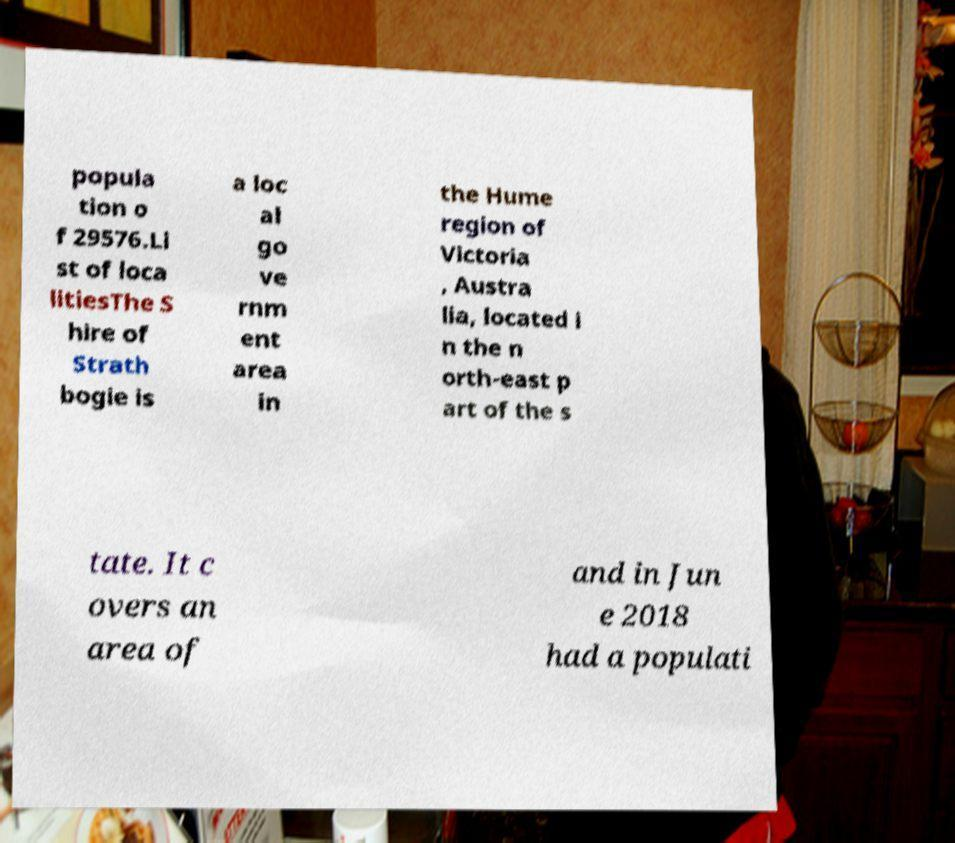For documentation purposes, I need the text within this image transcribed. Could you provide that? popula tion o f 29576.Li st of loca litiesThe S hire of Strath bogie is a loc al go ve rnm ent area in the Hume region of Victoria , Austra lia, located i n the n orth-east p art of the s tate. It c overs an area of and in Jun e 2018 had a populati 